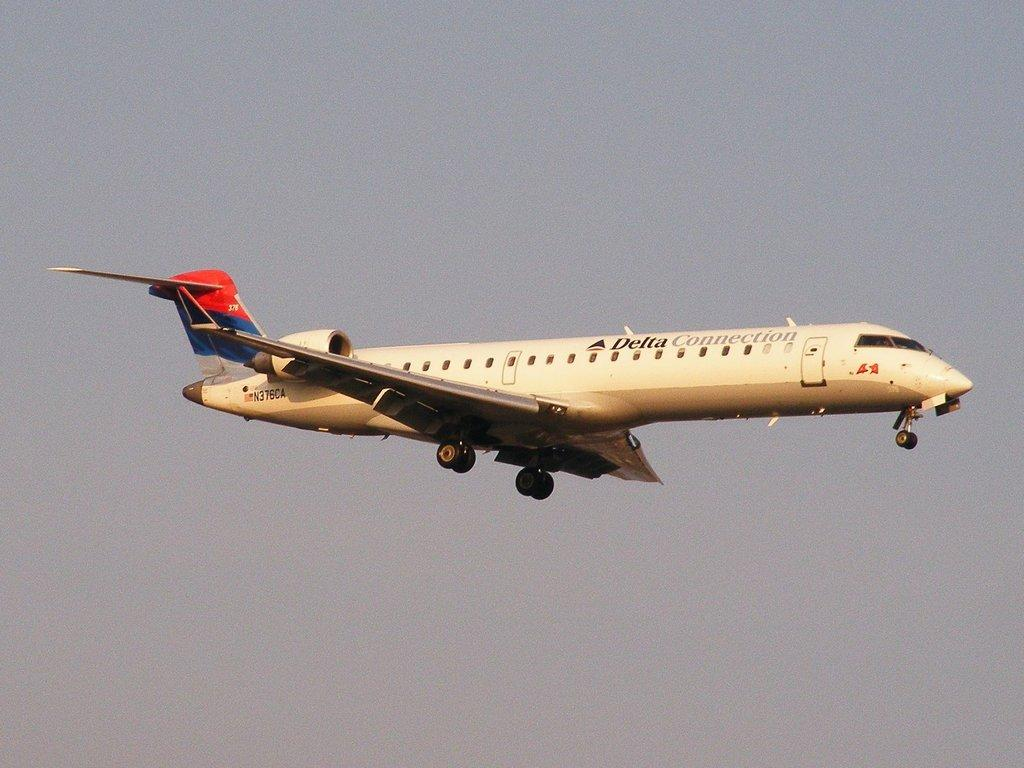<image>
Provide a brief description of the given image. Delta plane N376CA flies through the sky and its landing gear is down. 